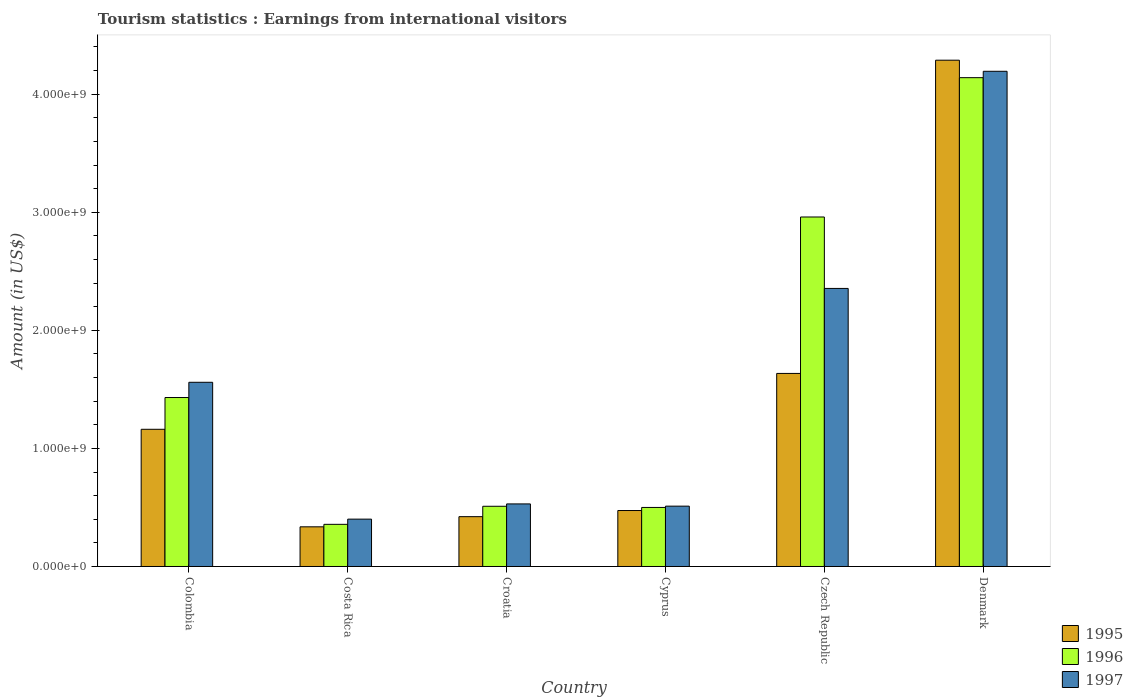Are the number of bars on each tick of the X-axis equal?
Your response must be concise. Yes. How many bars are there on the 3rd tick from the left?
Give a very brief answer. 3. What is the label of the 5th group of bars from the left?
Provide a succinct answer. Czech Republic. In how many cases, is the number of bars for a given country not equal to the number of legend labels?
Your answer should be very brief. 0. What is the earnings from international visitors in 1995 in Cyprus?
Your response must be concise. 4.74e+08. Across all countries, what is the maximum earnings from international visitors in 1996?
Offer a very short reply. 4.14e+09. Across all countries, what is the minimum earnings from international visitors in 1995?
Offer a terse response. 3.36e+08. In which country was the earnings from international visitors in 1996 minimum?
Keep it short and to the point. Costa Rica. What is the total earnings from international visitors in 1995 in the graph?
Give a very brief answer. 8.32e+09. What is the difference between the earnings from international visitors in 1995 in Cyprus and that in Denmark?
Offer a very short reply. -3.81e+09. What is the difference between the earnings from international visitors in 1996 in Czech Republic and the earnings from international visitors in 1995 in Cyprus?
Your response must be concise. 2.49e+09. What is the average earnings from international visitors in 1996 per country?
Your answer should be compact. 1.65e+09. What is the difference between the earnings from international visitors of/in 1996 and earnings from international visitors of/in 1995 in Costa Rica?
Provide a succinct answer. 2.10e+07. What is the ratio of the earnings from international visitors in 1997 in Cyprus to that in Czech Republic?
Keep it short and to the point. 0.22. Is the difference between the earnings from international visitors in 1996 in Cyprus and Czech Republic greater than the difference between the earnings from international visitors in 1995 in Cyprus and Czech Republic?
Make the answer very short. No. What is the difference between the highest and the second highest earnings from international visitors in 1997?
Your answer should be very brief. 2.63e+09. What is the difference between the highest and the lowest earnings from international visitors in 1997?
Provide a succinct answer. 3.79e+09. Is the sum of the earnings from international visitors in 1997 in Costa Rica and Denmark greater than the maximum earnings from international visitors in 1995 across all countries?
Provide a short and direct response. Yes. What does the 3rd bar from the left in Denmark represents?
Offer a very short reply. 1997. Does the graph contain any zero values?
Give a very brief answer. No. Does the graph contain grids?
Make the answer very short. No. Where does the legend appear in the graph?
Provide a short and direct response. Bottom right. What is the title of the graph?
Offer a terse response. Tourism statistics : Earnings from international visitors. Does "1976" appear as one of the legend labels in the graph?
Your response must be concise. No. What is the Amount (in US$) in 1995 in Colombia?
Offer a very short reply. 1.16e+09. What is the Amount (in US$) in 1996 in Colombia?
Provide a succinct answer. 1.43e+09. What is the Amount (in US$) of 1997 in Colombia?
Provide a short and direct response. 1.56e+09. What is the Amount (in US$) in 1995 in Costa Rica?
Your response must be concise. 3.36e+08. What is the Amount (in US$) in 1996 in Costa Rica?
Offer a very short reply. 3.57e+08. What is the Amount (in US$) in 1997 in Costa Rica?
Your answer should be compact. 4.01e+08. What is the Amount (in US$) of 1995 in Croatia?
Provide a short and direct response. 4.22e+08. What is the Amount (in US$) of 1996 in Croatia?
Offer a terse response. 5.10e+08. What is the Amount (in US$) of 1997 in Croatia?
Provide a succinct answer. 5.30e+08. What is the Amount (in US$) of 1995 in Cyprus?
Your response must be concise. 4.74e+08. What is the Amount (in US$) of 1997 in Cyprus?
Make the answer very short. 5.11e+08. What is the Amount (in US$) of 1995 in Czech Republic?
Your answer should be compact. 1.64e+09. What is the Amount (in US$) of 1996 in Czech Republic?
Your answer should be compact. 2.96e+09. What is the Amount (in US$) in 1997 in Czech Republic?
Your answer should be very brief. 2.36e+09. What is the Amount (in US$) of 1995 in Denmark?
Offer a very short reply. 4.29e+09. What is the Amount (in US$) of 1996 in Denmark?
Give a very brief answer. 4.14e+09. What is the Amount (in US$) of 1997 in Denmark?
Your response must be concise. 4.19e+09. Across all countries, what is the maximum Amount (in US$) in 1995?
Provide a succinct answer. 4.29e+09. Across all countries, what is the maximum Amount (in US$) of 1996?
Provide a short and direct response. 4.14e+09. Across all countries, what is the maximum Amount (in US$) of 1997?
Offer a terse response. 4.19e+09. Across all countries, what is the minimum Amount (in US$) in 1995?
Provide a succinct answer. 3.36e+08. Across all countries, what is the minimum Amount (in US$) of 1996?
Ensure brevity in your answer.  3.57e+08. Across all countries, what is the minimum Amount (in US$) of 1997?
Your answer should be very brief. 4.01e+08. What is the total Amount (in US$) in 1995 in the graph?
Offer a very short reply. 8.32e+09. What is the total Amount (in US$) of 1996 in the graph?
Your answer should be very brief. 9.90e+09. What is the total Amount (in US$) of 1997 in the graph?
Offer a very short reply. 9.55e+09. What is the difference between the Amount (in US$) in 1995 in Colombia and that in Costa Rica?
Offer a very short reply. 8.26e+08. What is the difference between the Amount (in US$) in 1996 in Colombia and that in Costa Rica?
Ensure brevity in your answer.  1.07e+09. What is the difference between the Amount (in US$) of 1997 in Colombia and that in Costa Rica?
Ensure brevity in your answer.  1.16e+09. What is the difference between the Amount (in US$) in 1995 in Colombia and that in Croatia?
Give a very brief answer. 7.40e+08. What is the difference between the Amount (in US$) in 1996 in Colombia and that in Croatia?
Give a very brief answer. 9.21e+08. What is the difference between the Amount (in US$) of 1997 in Colombia and that in Croatia?
Your response must be concise. 1.03e+09. What is the difference between the Amount (in US$) of 1995 in Colombia and that in Cyprus?
Provide a short and direct response. 6.88e+08. What is the difference between the Amount (in US$) in 1996 in Colombia and that in Cyprus?
Your answer should be compact. 9.31e+08. What is the difference between the Amount (in US$) of 1997 in Colombia and that in Cyprus?
Provide a succinct answer. 1.05e+09. What is the difference between the Amount (in US$) in 1995 in Colombia and that in Czech Republic?
Ensure brevity in your answer.  -4.73e+08. What is the difference between the Amount (in US$) in 1996 in Colombia and that in Czech Republic?
Make the answer very short. -1.53e+09. What is the difference between the Amount (in US$) of 1997 in Colombia and that in Czech Republic?
Your answer should be compact. -7.95e+08. What is the difference between the Amount (in US$) of 1995 in Colombia and that in Denmark?
Keep it short and to the point. -3.13e+09. What is the difference between the Amount (in US$) of 1996 in Colombia and that in Denmark?
Make the answer very short. -2.71e+09. What is the difference between the Amount (in US$) in 1997 in Colombia and that in Denmark?
Your answer should be very brief. -2.63e+09. What is the difference between the Amount (in US$) of 1995 in Costa Rica and that in Croatia?
Your answer should be very brief. -8.60e+07. What is the difference between the Amount (in US$) of 1996 in Costa Rica and that in Croatia?
Give a very brief answer. -1.53e+08. What is the difference between the Amount (in US$) in 1997 in Costa Rica and that in Croatia?
Ensure brevity in your answer.  -1.29e+08. What is the difference between the Amount (in US$) of 1995 in Costa Rica and that in Cyprus?
Make the answer very short. -1.38e+08. What is the difference between the Amount (in US$) of 1996 in Costa Rica and that in Cyprus?
Offer a very short reply. -1.43e+08. What is the difference between the Amount (in US$) in 1997 in Costa Rica and that in Cyprus?
Offer a terse response. -1.10e+08. What is the difference between the Amount (in US$) in 1995 in Costa Rica and that in Czech Republic?
Give a very brief answer. -1.30e+09. What is the difference between the Amount (in US$) in 1996 in Costa Rica and that in Czech Republic?
Ensure brevity in your answer.  -2.60e+09. What is the difference between the Amount (in US$) of 1997 in Costa Rica and that in Czech Republic?
Give a very brief answer. -1.95e+09. What is the difference between the Amount (in US$) of 1995 in Costa Rica and that in Denmark?
Offer a terse response. -3.95e+09. What is the difference between the Amount (in US$) in 1996 in Costa Rica and that in Denmark?
Your response must be concise. -3.78e+09. What is the difference between the Amount (in US$) in 1997 in Costa Rica and that in Denmark?
Your answer should be very brief. -3.79e+09. What is the difference between the Amount (in US$) in 1995 in Croatia and that in Cyprus?
Offer a very short reply. -5.20e+07. What is the difference between the Amount (in US$) in 1997 in Croatia and that in Cyprus?
Your answer should be compact. 1.90e+07. What is the difference between the Amount (in US$) of 1995 in Croatia and that in Czech Republic?
Ensure brevity in your answer.  -1.21e+09. What is the difference between the Amount (in US$) of 1996 in Croatia and that in Czech Republic?
Your response must be concise. -2.45e+09. What is the difference between the Amount (in US$) of 1997 in Croatia and that in Czech Republic?
Your answer should be compact. -1.82e+09. What is the difference between the Amount (in US$) of 1995 in Croatia and that in Denmark?
Your answer should be very brief. -3.87e+09. What is the difference between the Amount (in US$) in 1996 in Croatia and that in Denmark?
Keep it short and to the point. -3.63e+09. What is the difference between the Amount (in US$) of 1997 in Croatia and that in Denmark?
Provide a succinct answer. -3.66e+09. What is the difference between the Amount (in US$) in 1995 in Cyprus and that in Czech Republic?
Your response must be concise. -1.16e+09. What is the difference between the Amount (in US$) in 1996 in Cyprus and that in Czech Republic?
Ensure brevity in your answer.  -2.46e+09. What is the difference between the Amount (in US$) of 1997 in Cyprus and that in Czech Republic?
Your answer should be compact. -1.84e+09. What is the difference between the Amount (in US$) of 1995 in Cyprus and that in Denmark?
Keep it short and to the point. -3.81e+09. What is the difference between the Amount (in US$) in 1996 in Cyprus and that in Denmark?
Offer a terse response. -3.64e+09. What is the difference between the Amount (in US$) in 1997 in Cyprus and that in Denmark?
Your answer should be very brief. -3.68e+09. What is the difference between the Amount (in US$) in 1995 in Czech Republic and that in Denmark?
Give a very brief answer. -2.65e+09. What is the difference between the Amount (in US$) in 1996 in Czech Republic and that in Denmark?
Keep it short and to the point. -1.18e+09. What is the difference between the Amount (in US$) of 1997 in Czech Republic and that in Denmark?
Your response must be concise. -1.84e+09. What is the difference between the Amount (in US$) in 1995 in Colombia and the Amount (in US$) in 1996 in Costa Rica?
Your answer should be compact. 8.05e+08. What is the difference between the Amount (in US$) of 1995 in Colombia and the Amount (in US$) of 1997 in Costa Rica?
Make the answer very short. 7.61e+08. What is the difference between the Amount (in US$) in 1996 in Colombia and the Amount (in US$) in 1997 in Costa Rica?
Your answer should be very brief. 1.03e+09. What is the difference between the Amount (in US$) of 1995 in Colombia and the Amount (in US$) of 1996 in Croatia?
Keep it short and to the point. 6.52e+08. What is the difference between the Amount (in US$) in 1995 in Colombia and the Amount (in US$) in 1997 in Croatia?
Provide a short and direct response. 6.32e+08. What is the difference between the Amount (in US$) in 1996 in Colombia and the Amount (in US$) in 1997 in Croatia?
Offer a terse response. 9.01e+08. What is the difference between the Amount (in US$) of 1995 in Colombia and the Amount (in US$) of 1996 in Cyprus?
Provide a short and direct response. 6.62e+08. What is the difference between the Amount (in US$) of 1995 in Colombia and the Amount (in US$) of 1997 in Cyprus?
Your answer should be very brief. 6.51e+08. What is the difference between the Amount (in US$) in 1996 in Colombia and the Amount (in US$) in 1997 in Cyprus?
Your response must be concise. 9.20e+08. What is the difference between the Amount (in US$) of 1995 in Colombia and the Amount (in US$) of 1996 in Czech Republic?
Your answer should be compact. -1.80e+09. What is the difference between the Amount (in US$) in 1995 in Colombia and the Amount (in US$) in 1997 in Czech Republic?
Offer a very short reply. -1.19e+09. What is the difference between the Amount (in US$) of 1996 in Colombia and the Amount (in US$) of 1997 in Czech Republic?
Ensure brevity in your answer.  -9.24e+08. What is the difference between the Amount (in US$) of 1995 in Colombia and the Amount (in US$) of 1996 in Denmark?
Provide a short and direct response. -2.98e+09. What is the difference between the Amount (in US$) in 1995 in Colombia and the Amount (in US$) in 1997 in Denmark?
Ensure brevity in your answer.  -3.03e+09. What is the difference between the Amount (in US$) of 1996 in Colombia and the Amount (in US$) of 1997 in Denmark?
Your answer should be compact. -2.76e+09. What is the difference between the Amount (in US$) in 1995 in Costa Rica and the Amount (in US$) in 1996 in Croatia?
Give a very brief answer. -1.74e+08. What is the difference between the Amount (in US$) in 1995 in Costa Rica and the Amount (in US$) in 1997 in Croatia?
Give a very brief answer. -1.94e+08. What is the difference between the Amount (in US$) in 1996 in Costa Rica and the Amount (in US$) in 1997 in Croatia?
Ensure brevity in your answer.  -1.73e+08. What is the difference between the Amount (in US$) of 1995 in Costa Rica and the Amount (in US$) of 1996 in Cyprus?
Provide a succinct answer. -1.64e+08. What is the difference between the Amount (in US$) of 1995 in Costa Rica and the Amount (in US$) of 1997 in Cyprus?
Your answer should be compact. -1.75e+08. What is the difference between the Amount (in US$) of 1996 in Costa Rica and the Amount (in US$) of 1997 in Cyprus?
Keep it short and to the point. -1.54e+08. What is the difference between the Amount (in US$) of 1995 in Costa Rica and the Amount (in US$) of 1996 in Czech Republic?
Make the answer very short. -2.62e+09. What is the difference between the Amount (in US$) in 1995 in Costa Rica and the Amount (in US$) in 1997 in Czech Republic?
Make the answer very short. -2.02e+09. What is the difference between the Amount (in US$) in 1996 in Costa Rica and the Amount (in US$) in 1997 in Czech Republic?
Offer a terse response. -2.00e+09. What is the difference between the Amount (in US$) in 1995 in Costa Rica and the Amount (in US$) in 1996 in Denmark?
Provide a short and direct response. -3.80e+09. What is the difference between the Amount (in US$) in 1995 in Costa Rica and the Amount (in US$) in 1997 in Denmark?
Keep it short and to the point. -3.86e+09. What is the difference between the Amount (in US$) in 1996 in Costa Rica and the Amount (in US$) in 1997 in Denmark?
Give a very brief answer. -3.84e+09. What is the difference between the Amount (in US$) in 1995 in Croatia and the Amount (in US$) in 1996 in Cyprus?
Your response must be concise. -7.80e+07. What is the difference between the Amount (in US$) of 1995 in Croatia and the Amount (in US$) of 1997 in Cyprus?
Your answer should be compact. -8.90e+07. What is the difference between the Amount (in US$) of 1996 in Croatia and the Amount (in US$) of 1997 in Cyprus?
Give a very brief answer. -1.00e+06. What is the difference between the Amount (in US$) in 1995 in Croatia and the Amount (in US$) in 1996 in Czech Republic?
Keep it short and to the point. -2.54e+09. What is the difference between the Amount (in US$) of 1995 in Croatia and the Amount (in US$) of 1997 in Czech Republic?
Make the answer very short. -1.93e+09. What is the difference between the Amount (in US$) in 1996 in Croatia and the Amount (in US$) in 1997 in Czech Republic?
Your response must be concise. -1.84e+09. What is the difference between the Amount (in US$) in 1995 in Croatia and the Amount (in US$) in 1996 in Denmark?
Provide a short and direct response. -3.72e+09. What is the difference between the Amount (in US$) in 1995 in Croatia and the Amount (in US$) in 1997 in Denmark?
Ensure brevity in your answer.  -3.77e+09. What is the difference between the Amount (in US$) in 1996 in Croatia and the Amount (in US$) in 1997 in Denmark?
Make the answer very short. -3.68e+09. What is the difference between the Amount (in US$) of 1995 in Cyprus and the Amount (in US$) of 1996 in Czech Republic?
Your response must be concise. -2.49e+09. What is the difference between the Amount (in US$) of 1995 in Cyprus and the Amount (in US$) of 1997 in Czech Republic?
Ensure brevity in your answer.  -1.88e+09. What is the difference between the Amount (in US$) of 1996 in Cyprus and the Amount (in US$) of 1997 in Czech Republic?
Your response must be concise. -1.86e+09. What is the difference between the Amount (in US$) in 1995 in Cyprus and the Amount (in US$) in 1996 in Denmark?
Give a very brief answer. -3.67e+09. What is the difference between the Amount (in US$) of 1995 in Cyprus and the Amount (in US$) of 1997 in Denmark?
Your answer should be very brief. -3.72e+09. What is the difference between the Amount (in US$) in 1996 in Cyprus and the Amount (in US$) in 1997 in Denmark?
Offer a very short reply. -3.69e+09. What is the difference between the Amount (in US$) in 1995 in Czech Republic and the Amount (in US$) in 1996 in Denmark?
Your answer should be compact. -2.50e+09. What is the difference between the Amount (in US$) of 1995 in Czech Republic and the Amount (in US$) of 1997 in Denmark?
Offer a very short reply. -2.56e+09. What is the difference between the Amount (in US$) in 1996 in Czech Republic and the Amount (in US$) in 1997 in Denmark?
Offer a terse response. -1.23e+09. What is the average Amount (in US$) of 1995 per country?
Your answer should be very brief. 1.39e+09. What is the average Amount (in US$) of 1996 per country?
Your response must be concise. 1.65e+09. What is the average Amount (in US$) in 1997 per country?
Keep it short and to the point. 1.59e+09. What is the difference between the Amount (in US$) of 1995 and Amount (in US$) of 1996 in Colombia?
Ensure brevity in your answer.  -2.69e+08. What is the difference between the Amount (in US$) in 1995 and Amount (in US$) in 1997 in Colombia?
Make the answer very short. -3.98e+08. What is the difference between the Amount (in US$) of 1996 and Amount (in US$) of 1997 in Colombia?
Your answer should be compact. -1.29e+08. What is the difference between the Amount (in US$) in 1995 and Amount (in US$) in 1996 in Costa Rica?
Make the answer very short. -2.10e+07. What is the difference between the Amount (in US$) of 1995 and Amount (in US$) of 1997 in Costa Rica?
Keep it short and to the point. -6.50e+07. What is the difference between the Amount (in US$) of 1996 and Amount (in US$) of 1997 in Costa Rica?
Ensure brevity in your answer.  -4.40e+07. What is the difference between the Amount (in US$) of 1995 and Amount (in US$) of 1996 in Croatia?
Give a very brief answer. -8.80e+07. What is the difference between the Amount (in US$) in 1995 and Amount (in US$) in 1997 in Croatia?
Provide a succinct answer. -1.08e+08. What is the difference between the Amount (in US$) in 1996 and Amount (in US$) in 1997 in Croatia?
Ensure brevity in your answer.  -2.00e+07. What is the difference between the Amount (in US$) in 1995 and Amount (in US$) in 1996 in Cyprus?
Offer a terse response. -2.60e+07. What is the difference between the Amount (in US$) of 1995 and Amount (in US$) of 1997 in Cyprus?
Ensure brevity in your answer.  -3.70e+07. What is the difference between the Amount (in US$) of 1996 and Amount (in US$) of 1997 in Cyprus?
Give a very brief answer. -1.10e+07. What is the difference between the Amount (in US$) of 1995 and Amount (in US$) of 1996 in Czech Republic?
Offer a terse response. -1.32e+09. What is the difference between the Amount (in US$) in 1995 and Amount (in US$) in 1997 in Czech Republic?
Your answer should be very brief. -7.20e+08. What is the difference between the Amount (in US$) in 1996 and Amount (in US$) in 1997 in Czech Republic?
Your answer should be compact. 6.05e+08. What is the difference between the Amount (in US$) of 1995 and Amount (in US$) of 1996 in Denmark?
Your response must be concise. 1.48e+08. What is the difference between the Amount (in US$) in 1995 and Amount (in US$) in 1997 in Denmark?
Make the answer very short. 9.40e+07. What is the difference between the Amount (in US$) of 1996 and Amount (in US$) of 1997 in Denmark?
Offer a very short reply. -5.40e+07. What is the ratio of the Amount (in US$) in 1995 in Colombia to that in Costa Rica?
Offer a terse response. 3.46. What is the ratio of the Amount (in US$) of 1996 in Colombia to that in Costa Rica?
Your response must be concise. 4.01. What is the ratio of the Amount (in US$) of 1997 in Colombia to that in Costa Rica?
Your answer should be very brief. 3.89. What is the ratio of the Amount (in US$) of 1995 in Colombia to that in Croatia?
Give a very brief answer. 2.75. What is the ratio of the Amount (in US$) of 1996 in Colombia to that in Croatia?
Provide a succinct answer. 2.81. What is the ratio of the Amount (in US$) in 1997 in Colombia to that in Croatia?
Your response must be concise. 2.94. What is the ratio of the Amount (in US$) in 1995 in Colombia to that in Cyprus?
Your answer should be compact. 2.45. What is the ratio of the Amount (in US$) in 1996 in Colombia to that in Cyprus?
Offer a very short reply. 2.86. What is the ratio of the Amount (in US$) of 1997 in Colombia to that in Cyprus?
Your answer should be compact. 3.05. What is the ratio of the Amount (in US$) in 1995 in Colombia to that in Czech Republic?
Give a very brief answer. 0.71. What is the ratio of the Amount (in US$) of 1996 in Colombia to that in Czech Republic?
Provide a short and direct response. 0.48. What is the ratio of the Amount (in US$) of 1997 in Colombia to that in Czech Republic?
Make the answer very short. 0.66. What is the ratio of the Amount (in US$) in 1995 in Colombia to that in Denmark?
Give a very brief answer. 0.27. What is the ratio of the Amount (in US$) of 1996 in Colombia to that in Denmark?
Your answer should be very brief. 0.35. What is the ratio of the Amount (in US$) of 1997 in Colombia to that in Denmark?
Offer a terse response. 0.37. What is the ratio of the Amount (in US$) in 1995 in Costa Rica to that in Croatia?
Give a very brief answer. 0.8. What is the ratio of the Amount (in US$) of 1996 in Costa Rica to that in Croatia?
Your answer should be very brief. 0.7. What is the ratio of the Amount (in US$) in 1997 in Costa Rica to that in Croatia?
Keep it short and to the point. 0.76. What is the ratio of the Amount (in US$) of 1995 in Costa Rica to that in Cyprus?
Provide a succinct answer. 0.71. What is the ratio of the Amount (in US$) of 1996 in Costa Rica to that in Cyprus?
Your answer should be compact. 0.71. What is the ratio of the Amount (in US$) of 1997 in Costa Rica to that in Cyprus?
Provide a short and direct response. 0.78. What is the ratio of the Amount (in US$) of 1995 in Costa Rica to that in Czech Republic?
Offer a very short reply. 0.21. What is the ratio of the Amount (in US$) of 1996 in Costa Rica to that in Czech Republic?
Your answer should be very brief. 0.12. What is the ratio of the Amount (in US$) in 1997 in Costa Rica to that in Czech Republic?
Make the answer very short. 0.17. What is the ratio of the Amount (in US$) of 1995 in Costa Rica to that in Denmark?
Give a very brief answer. 0.08. What is the ratio of the Amount (in US$) in 1996 in Costa Rica to that in Denmark?
Ensure brevity in your answer.  0.09. What is the ratio of the Amount (in US$) of 1997 in Costa Rica to that in Denmark?
Your answer should be very brief. 0.1. What is the ratio of the Amount (in US$) in 1995 in Croatia to that in Cyprus?
Your answer should be very brief. 0.89. What is the ratio of the Amount (in US$) of 1997 in Croatia to that in Cyprus?
Your response must be concise. 1.04. What is the ratio of the Amount (in US$) in 1995 in Croatia to that in Czech Republic?
Provide a succinct answer. 0.26. What is the ratio of the Amount (in US$) of 1996 in Croatia to that in Czech Republic?
Keep it short and to the point. 0.17. What is the ratio of the Amount (in US$) in 1997 in Croatia to that in Czech Republic?
Your response must be concise. 0.23. What is the ratio of the Amount (in US$) of 1995 in Croatia to that in Denmark?
Your answer should be very brief. 0.1. What is the ratio of the Amount (in US$) of 1996 in Croatia to that in Denmark?
Give a very brief answer. 0.12. What is the ratio of the Amount (in US$) of 1997 in Croatia to that in Denmark?
Provide a short and direct response. 0.13. What is the ratio of the Amount (in US$) in 1995 in Cyprus to that in Czech Republic?
Ensure brevity in your answer.  0.29. What is the ratio of the Amount (in US$) in 1996 in Cyprus to that in Czech Republic?
Keep it short and to the point. 0.17. What is the ratio of the Amount (in US$) in 1997 in Cyprus to that in Czech Republic?
Ensure brevity in your answer.  0.22. What is the ratio of the Amount (in US$) in 1995 in Cyprus to that in Denmark?
Ensure brevity in your answer.  0.11. What is the ratio of the Amount (in US$) of 1996 in Cyprus to that in Denmark?
Your answer should be very brief. 0.12. What is the ratio of the Amount (in US$) in 1997 in Cyprus to that in Denmark?
Offer a terse response. 0.12. What is the ratio of the Amount (in US$) in 1995 in Czech Republic to that in Denmark?
Your response must be concise. 0.38. What is the ratio of the Amount (in US$) in 1996 in Czech Republic to that in Denmark?
Offer a terse response. 0.71. What is the ratio of the Amount (in US$) of 1997 in Czech Republic to that in Denmark?
Offer a very short reply. 0.56. What is the difference between the highest and the second highest Amount (in US$) in 1995?
Your answer should be very brief. 2.65e+09. What is the difference between the highest and the second highest Amount (in US$) of 1996?
Give a very brief answer. 1.18e+09. What is the difference between the highest and the second highest Amount (in US$) of 1997?
Your answer should be compact. 1.84e+09. What is the difference between the highest and the lowest Amount (in US$) of 1995?
Keep it short and to the point. 3.95e+09. What is the difference between the highest and the lowest Amount (in US$) in 1996?
Give a very brief answer. 3.78e+09. What is the difference between the highest and the lowest Amount (in US$) in 1997?
Your answer should be very brief. 3.79e+09. 